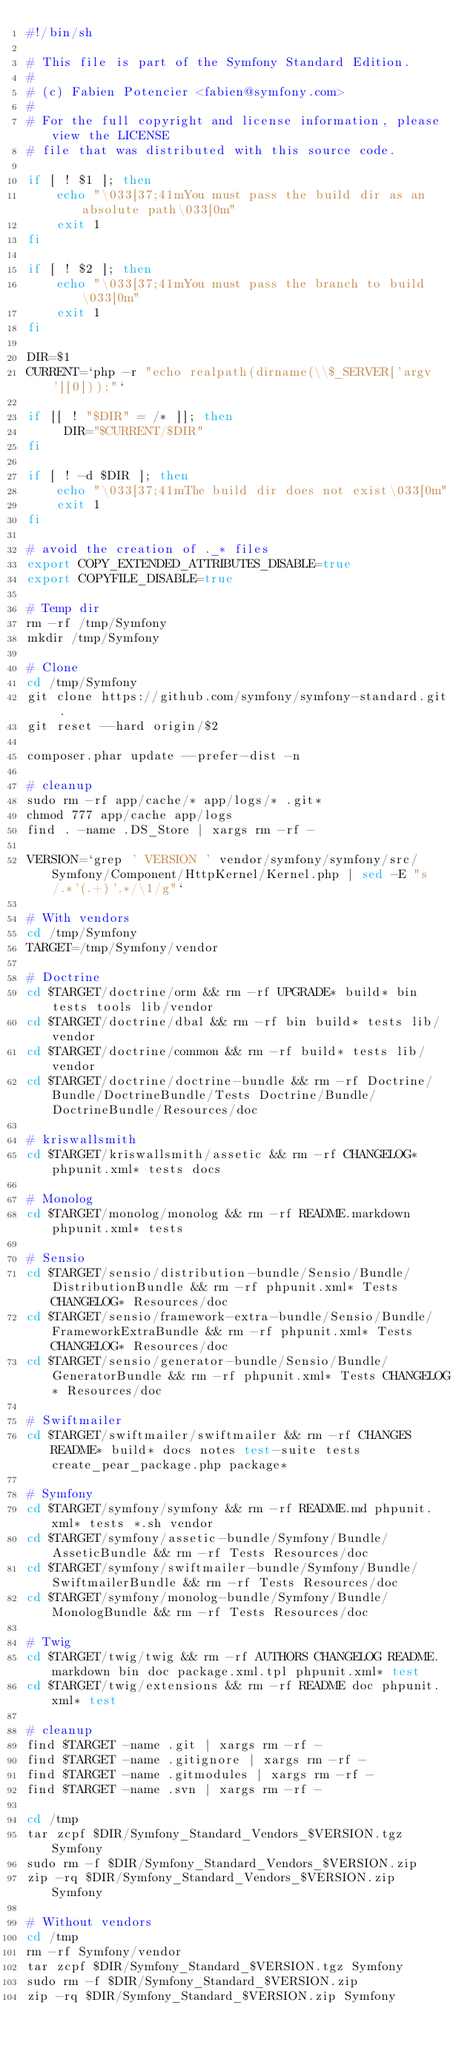Convert code to text. <code><loc_0><loc_0><loc_500><loc_500><_Bash_>#!/bin/sh

# This file is part of the Symfony Standard Edition.
#
# (c) Fabien Potencier <fabien@symfony.com>
#
# For the full copyright and license information, please view the LICENSE
# file that was distributed with this source code.

if [ ! $1 ]; then
    echo "\033[37;41mYou must pass the build dir as an absolute path\033[0m"
    exit 1
fi

if [ ! $2 ]; then
    echo "\033[37;41mYou must pass the branch to build\033[0m"
    exit 1
fi

DIR=$1
CURRENT=`php -r "echo realpath(dirname(\\$_SERVER['argv'][0]));"`

if [[ ! "$DIR" = /* ]]; then
     DIR="$CURRENT/$DIR"
fi

if [ ! -d $DIR ]; then
    echo "\033[37;41mThe build dir does not exist\033[0m"
    exit 1
fi

# avoid the creation of ._* files
export COPY_EXTENDED_ATTRIBUTES_DISABLE=true
export COPYFILE_DISABLE=true

# Temp dir
rm -rf /tmp/Symfony
mkdir /tmp/Symfony

# Clone
cd /tmp/Symfony
git clone https://github.com/symfony/symfony-standard.git .
git reset --hard origin/$2

composer.phar update --prefer-dist -n

# cleanup
sudo rm -rf app/cache/* app/logs/* .git*
chmod 777 app/cache app/logs
find . -name .DS_Store | xargs rm -rf -

VERSION=`grep ' VERSION ' vendor/symfony/symfony/src/Symfony/Component/HttpKernel/Kernel.php | sed -E "s/.*'(.+)'.*/\1/g"`

# With vendors
cd /tmp/Symfony
TARGET=/tmp/Symfony/vendor

# Doctrine
cd $TARGET/doctrine/orm && rm -rf UPGRADE* build* bin tests tools lib/vendor
cd $TARGET/doctrine/dbal && rm -rf bin build* tests lib/vendor
cd $TARGET/doctrine/common && rm -rf build* tests lib/vendor
cd $TARGET/doctrine/doctrine-bundle && rm -rf Doctrine/Bundle/DoctrineBundle/Tests Doctrine/Bundle/DoctrineBundle/Resources/doc

# kriswallsmith
cd $TARGET/kriswallsmith/assetic && rm -rf CHANGELOG* phpunit.xml* tests docs

# Monolog
cd $TARGET/monolog/monolog && rm -rf README.markdown phpunit.xml* tests

# Sensio
cd $TARGET/sensio/distribution-bundle/Sensio/Bundle/DistributionBundle && rm -rf phpunit.xml* Tests CHANGELOG* Resources/doc
cd $TARGET/sensio/framework-extra-bundle/Sensio/Bundle/FrameworkExtraBundle && rm -rf phpunit.xml* Tests CHANGELOG* Resources/doc
cd $TARGET/sensio/generator-bundle/Sensio/Bundle/GeneratorBundle && rm -rf phpunit.xml* Tests CHANGELOG* Resources/doc

# Swiftmailer
cd $TARGET/swiftmailer/swiftmailer && rm -rf CHANGES README* build* docs notes test-suite tests create_pear_package.php package*

# Symfony
cd $TARGET/symfony/symfony && rm -rf README.md phpunit.xml* tests *.sh vendor
cd $TARGET/symfony/assetic-bundle/Symfony/Bundle/AsseticBundle && rm -rf Tests Resources/doc
cd $TARGET/symfony/swiftmailer-bundle/Symfony/Bundle/SwiftmailerBundle && rm -rf Tests Resources/doc
cd $TARGET/symfony/monolog-bundle/Symfony/Bundle/MonologBundle && rm -rf Tests Resources/doc

# Twig
cd $TARGET/twig/twig && rm -rf AUTHORS CHANGELOG README.markdown bin doc package.xml.tpl phpunit.xml* test
cd $TARGET/twig/extensions && rm -rf README doc phpunit.xml* test

# cleanup
find $TARGET -name .git | xargs rm -rf -
find $TARGET -name .gitignore | xargs rm -rf -
find $TARGET -name .gitmodules | xargs rm -rf -
find $TARGET -name .svn | xargs rm -rf -

cd /tmp
tar zcpf $DIR/Symfony_Standard_Vendors_$VERSION.tgz Symfony
sudo rm -f $DIR/Symfony_Standard_Vendors_$VERSION.zip
zip -rq $DIR/Symfony_Standard_Vendors_$VERSION.zip Symfony

# Without vendors
cd /tmp
rm -rf Symfony/vendor
tar zcpf $DIR/Symfony_Standard_$VERSION.tgz Symfony
sudo rm -f $DIR/Symfony_Standard_$VERSION.zip
zip -rq $DIR/Symfony_Standard_$VERSION.zip Symfony
</code> 